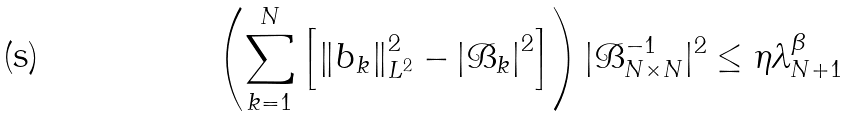Convert formula to latex. <formula><loc_0><loc_0><loc_500><loc_500>\left ( \sum _ { k = 1 } ^ { N } \left [ \left \| b _ { k } \right \| ^ { 2 } _ { L ^ { 2 } } - \left | \mathcal { B } _ { k } \right | ^ { 2 } \right ] \right ) | \mathcal { B } _ { N \times N } ^ { - 1 } | ^ { 2 } \leq \eta \lambda _ { N + 1 } ^ { \beta }</formula> 